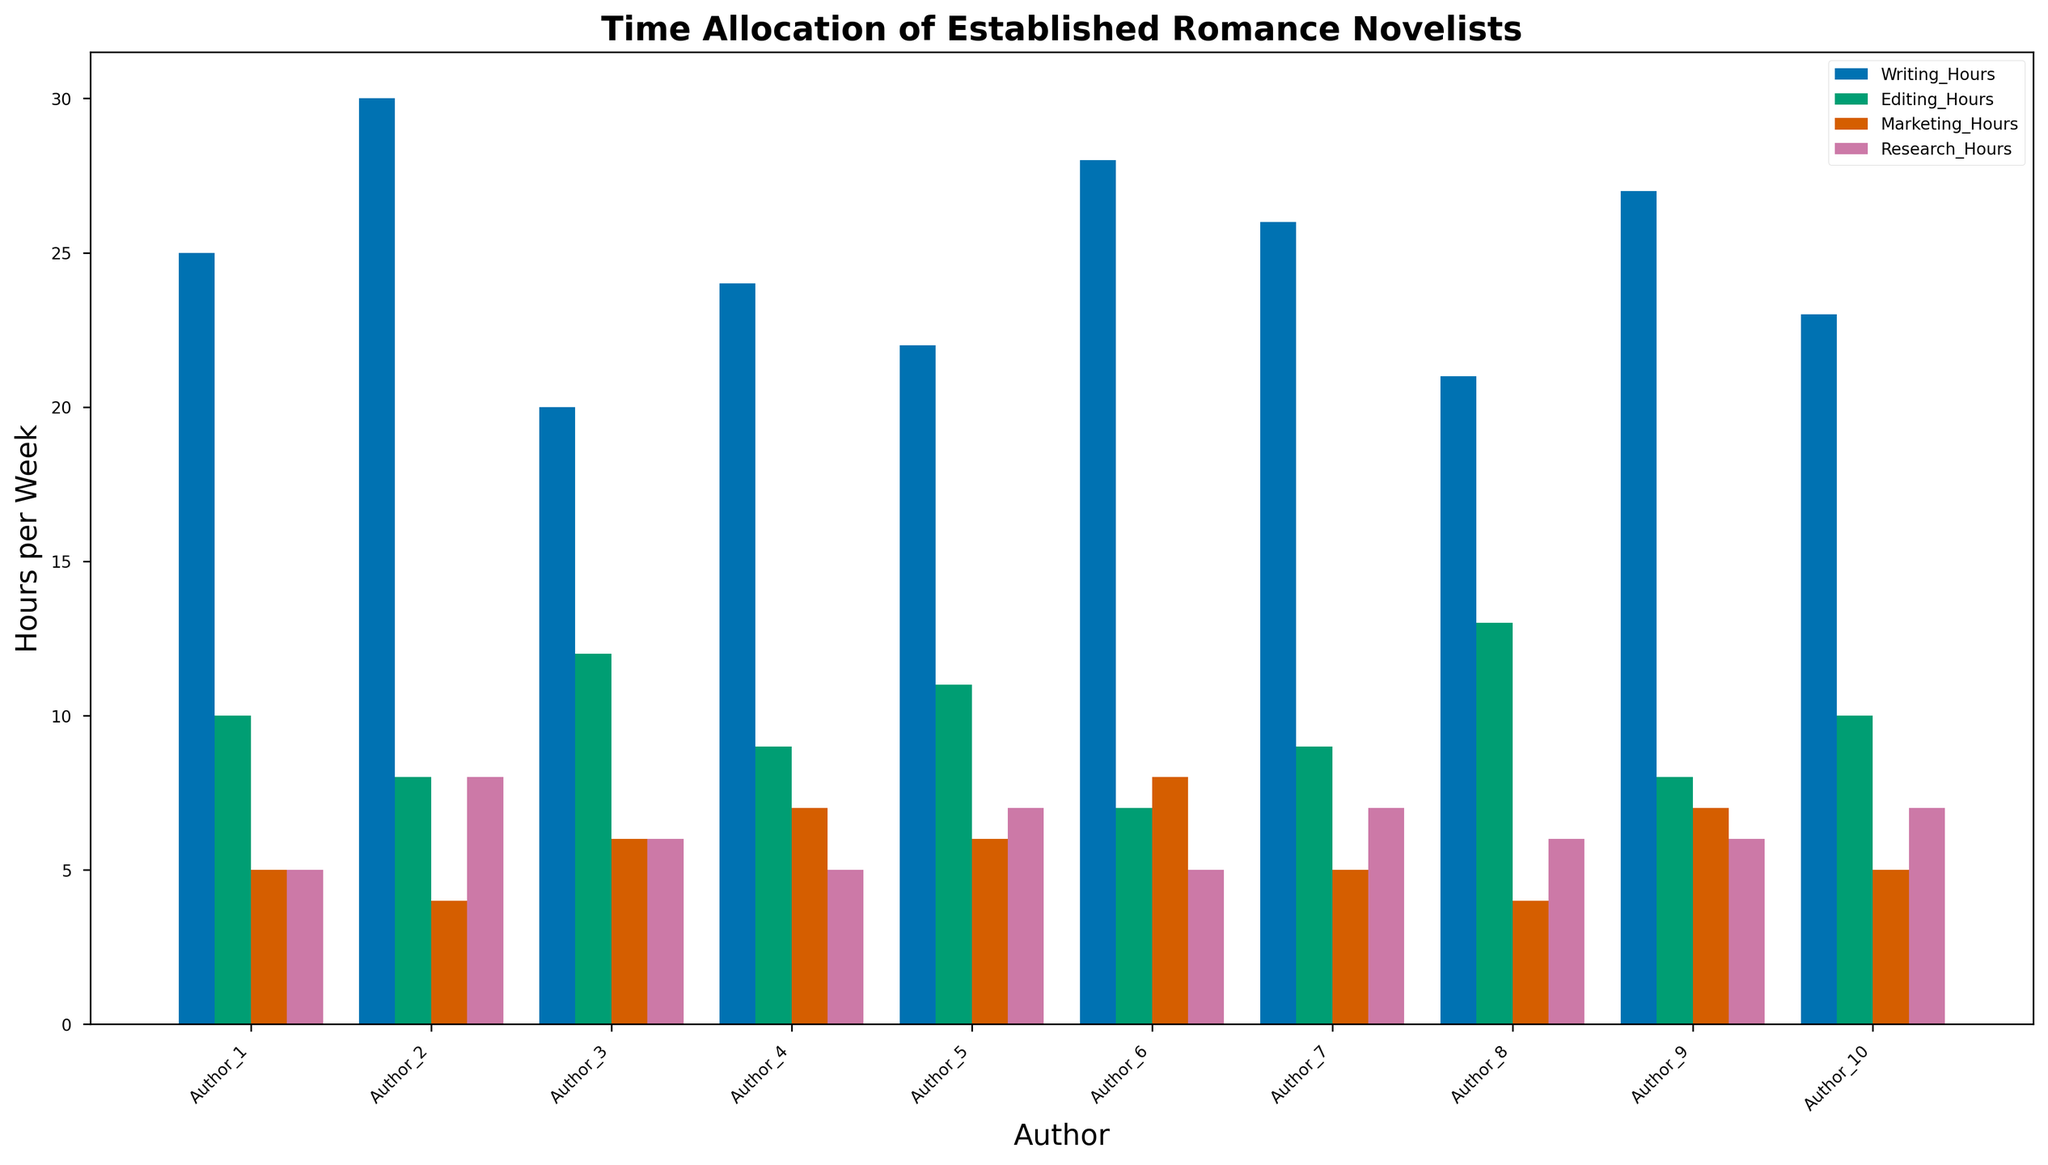Which author spends the most time writing? By comparing the heights of the writing bars for each author, we see that Author_2 has the tallest bar.
Answer: Author_2 What is the total time Author_3 spends on all activities? Sum the hours Author_3 spends on writing, editing, marketing, and research (20 + 12 + 6 + 6).
Answer: 44 hours Which activity does Author_9 spend the least time on? Compare the heights of the bars for Author_9 and note the shortest one, which is marketing.
Answer: Marketing Who spends more time on research, Author_4 or Author_5? Compare the heights of the research bars for Author_4 and Author_5; Author_5's research bar is taller.
Answer: Author_5 Which authors spend equal time on marketing? Look for bars of equal height in the marketing category; Author_1, Author_8, and Author_10 all spend 4 hours on marketing.
Answer: Author_1, Author_8, Author_10 What is the average writing time for all authors? Sum writing hours for all authors and divide by the number of authors ((25 + 30 + 20 + 24 + 22 + 28 + 26 + 21 + 27 + 23) / 10).
Answer: 24.6 hours Which author spends the most combined time on editing and marketing? Sum editing and marketing hours for each author and identify the largest sum, which belongs to Author_8 (13 + 4).
Answer: Author_8 How many hours does Author_6 dedicate to non-writing activities (editing, marketing, research)? Sum the editing, marketing, and research hours for Author_6 (7 + 8 + 5).
Answer: 20 hours What is the difference in writing hours between Author_1 and Author_7? Subtract Author_1's writing hours from Author_7's writing hours (26 - 25).
Answer: 1 hour Which author balances their time most evenly across all activities? Compare the bars of each author and look for the least variation in height; Author_10 has relatively even bars across all activities.
Answer: Author_10 